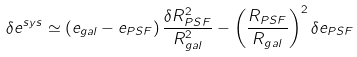<formula> <loc_0><loc_0><loc_500><loc_500>\delta e ^ { s y s } \simeq \left ( e _ { g a l } - e _ { P S F } \right ) \frac { \delta R ^ { 2 } _ { P S F } } { R ^ { 2 } _ { g a l } } - \left ( \frac { R _ { P S F } } { R _ { g a l } } \right ) ^ { 2 } \delta e _ { P S F }</formula> 